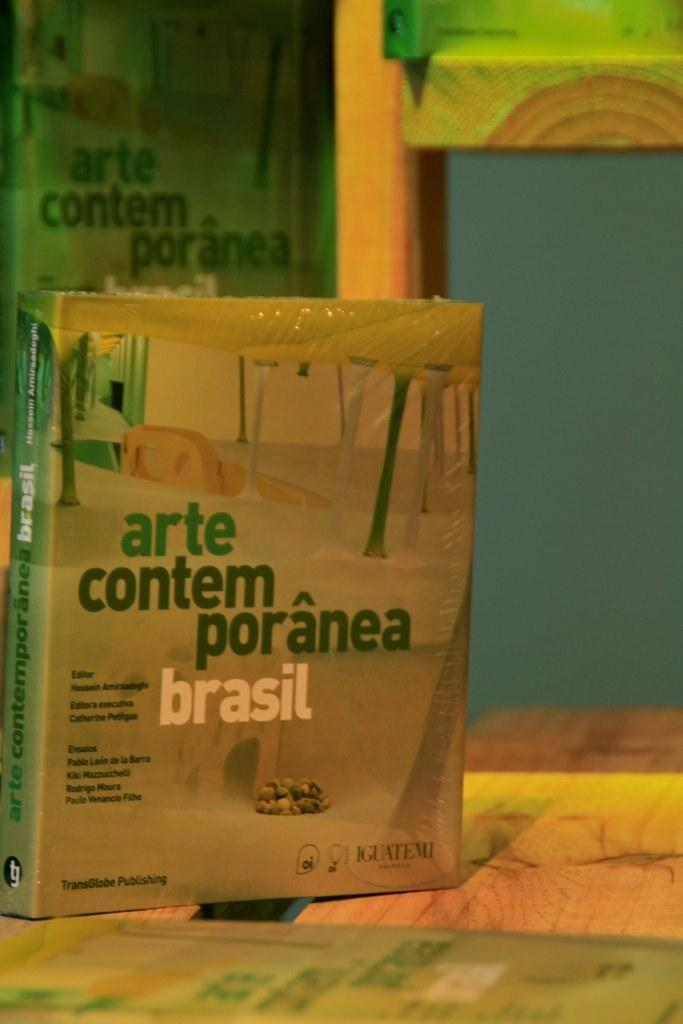Provide a one-sentence caption for the provided image. A brown and green book titled Arte Contemporanea Brasil. 